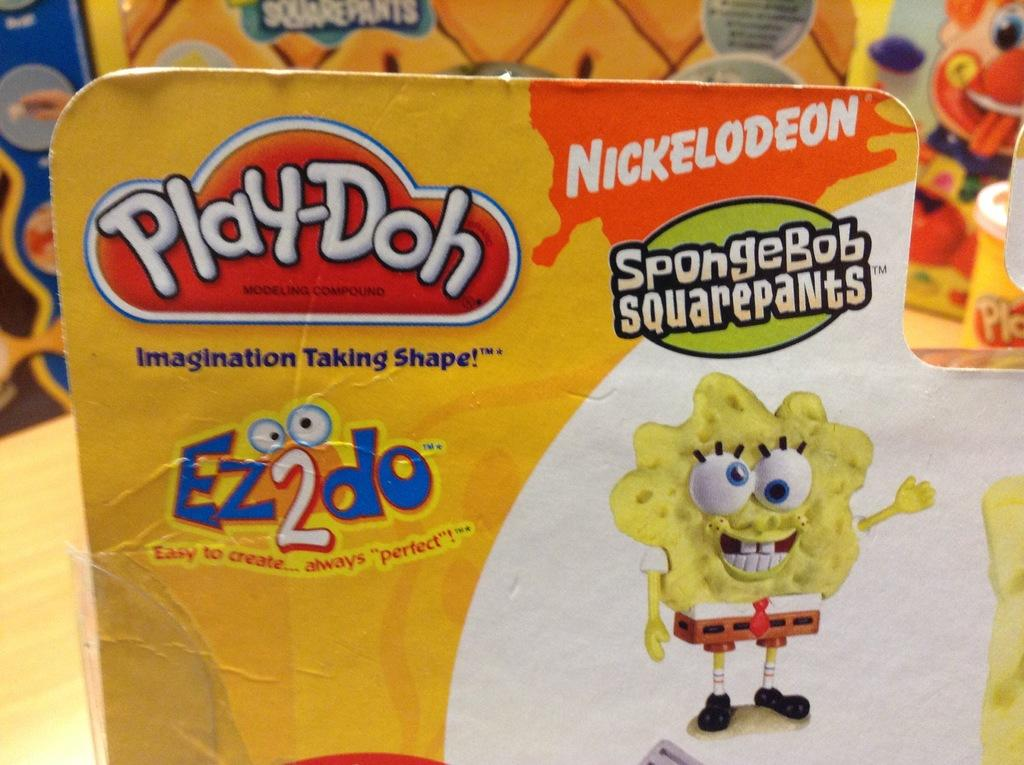What is the main object in the image? There is a card in the image. What can be found on the card? The card has text and a cartoon image on it. Can you describe the background of the image? The background of the image is blurry. What type of root can be seen growing from the cartoon image on the card? There is no root visible on the card; it only has text and a cartoon image. How does the anger of the cartoon character on the card affect the text? There is no indication of anger in the cartoon image on the card, and the text is not affected by any emotions. 